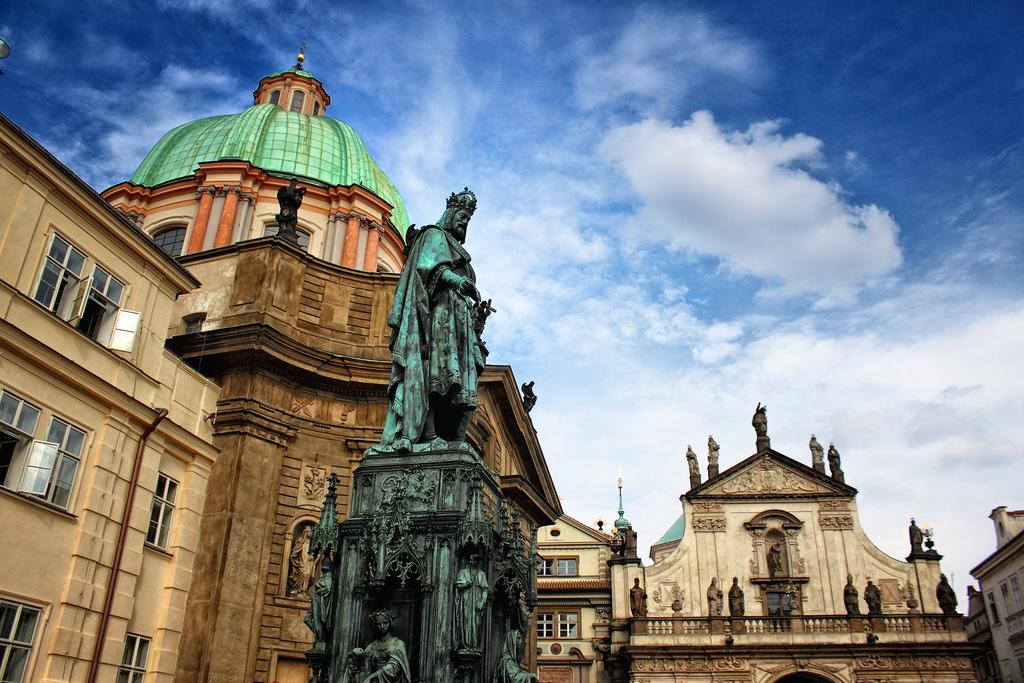What is the main subject in the image? There is a statue in the image. What else can be seen in the image besides the statue? There are buildings in the image. Are there any other statues in the image? Yes, there is a building with statues in the image. What can be seen in the background of the image? The sky is visible in the background of the image. What is the condition of the sky in the image? Clouds are present in the sky. What is the tendency of the police in the image? There is no police presence in the image, so it is not possible to determine their tendency. 